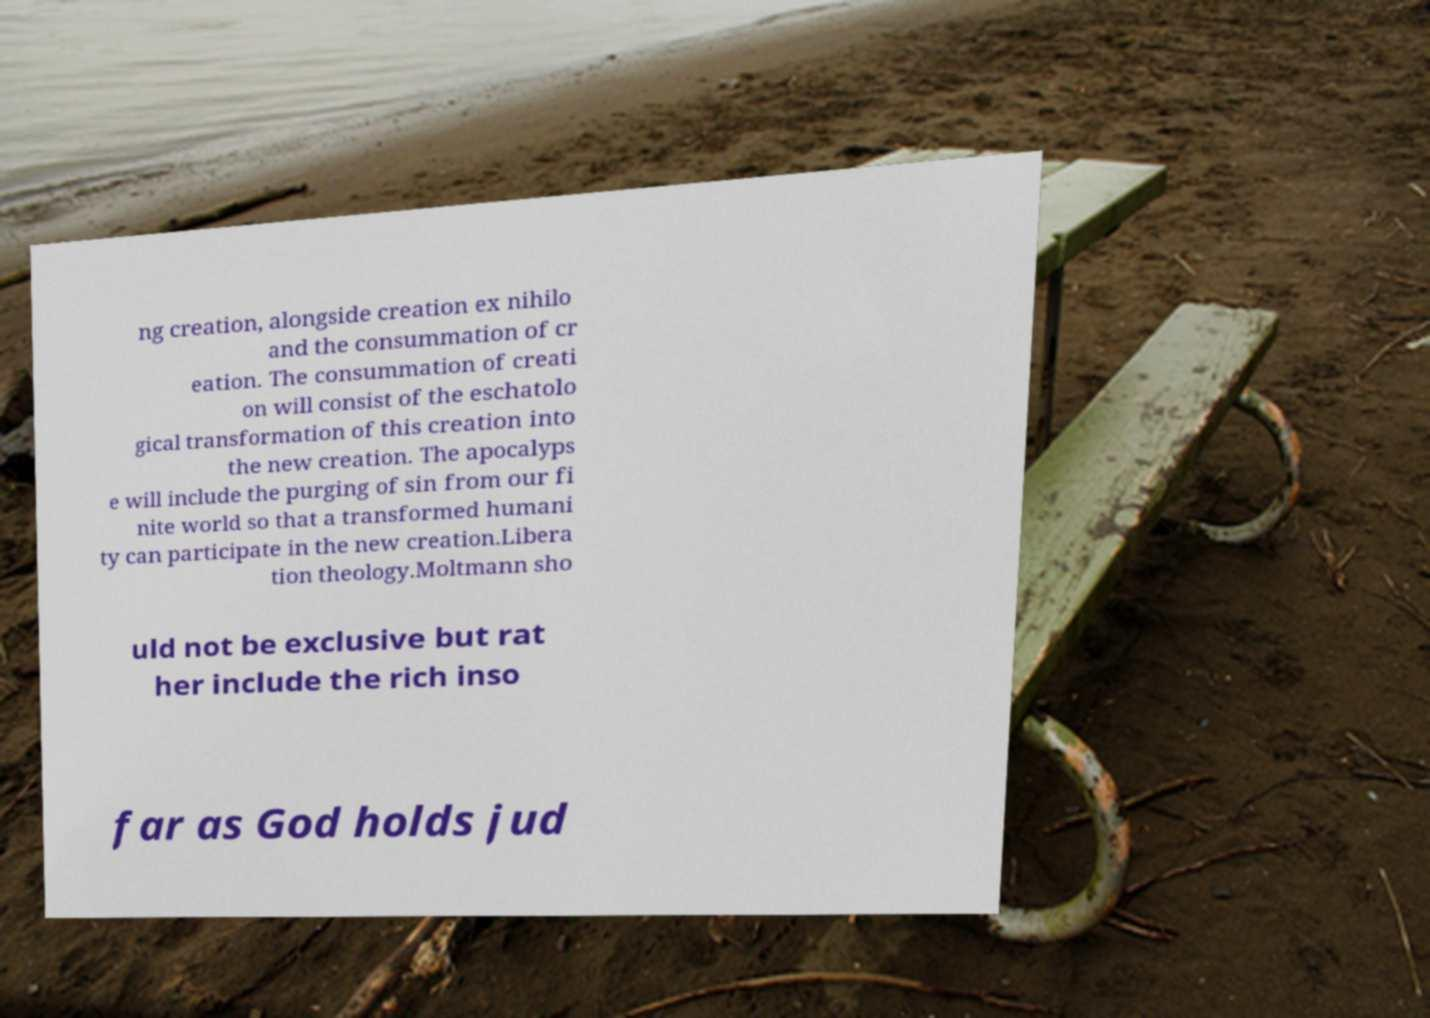Can you accurately transcribe the text from the provided image for me? ng creation, alongside creation ex nihilo and the consummation of cr eation. The consummation of creati on will consist of the eschatolo gical transformation of this creation into the new creation. The apocalyps e will include the purging of sin from our fi nite world so that a transformed humani ty can participate in the new creation.Libera tion theology.Moltmann sho uld not be exclusive but rat her include the rich inso far as God holds jud 